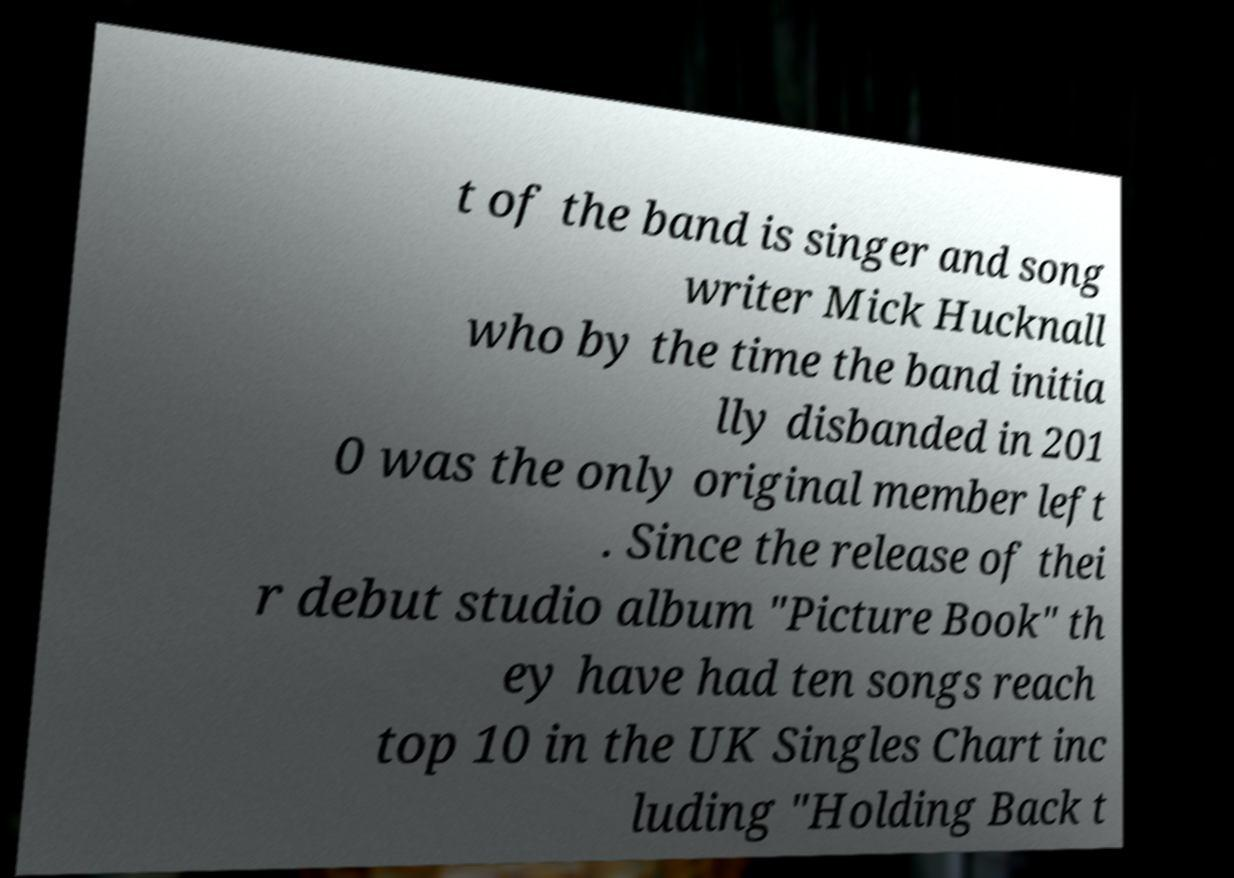Please identify and transcribe the text found in this image. t of the band is singer and song writer Mick Hucknall who by the time the band initia lly disbanded in 201 0 was the only original member left . Since the release of thei r debut studio album "Picture Book" th ey have had ten songs reach top 10 in the UK Singles Chart inc luding "Holding Back t 